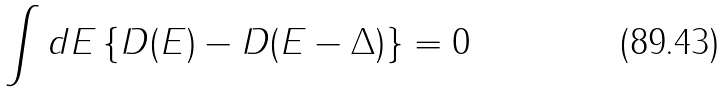<formula> <loc_0><loc_0><loc_500><loc_500>\int d E \left \{ D ( E ) - D ( E - \Delta ) \right \} = 0</formula> 